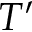<formula> <loc_0><loc_0><loc_500><loc_500>T ^ { \prime }</formula> 